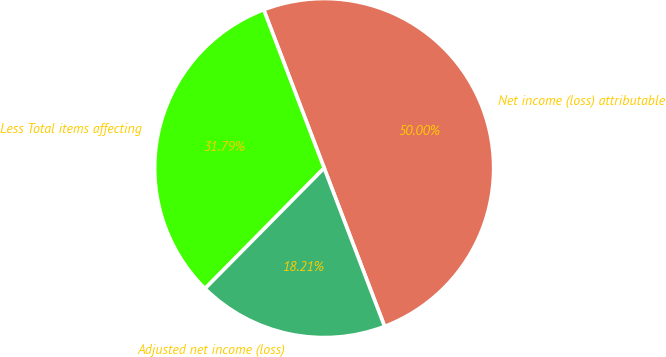Convert chart. <chart><loc_0><loc_0><loc_500><loc_500><pie_chart><fcel>Net income (loss) attributable<fcel>Less Total items affecting<fcel>Adjusted net income (loss)<nl><fcel>50.0%<fcel>31.79%<fcel>18.21%<nl></chart> 